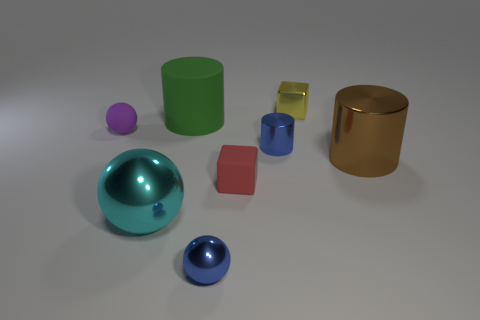There is a cylinder that is behind the blue metallic thing behind the large sphere; are there any purple rubber balls that are to the right of it?
Your answer should be very brief. No. Is there anything else that has the same size as the brown shiny thing?
Provide a succinct answer. Yes. There is a big cyan metallic object; does it have the same shape as the metallic object that is behind the tiny purple sphere?
Your response must be concise. No. There is a tiny metal thing that is in front of the small rubber thing that is in front of the small blue shiny thing that is behind the tiny blue ball; what is its color?
Offer a terse response. Blue. How many objects are balls right of the matte cylinder or small blue things in front of the big brown object?
Make the answer very short. 1. What number of other objects are the same color as the big metal cylinder?
Make the answer very short. 0. There is a large metal object right of the metallic block; does it have the same shape as the small purple rubber object?
Your answer should be compact. No. Are there fewer shiny blocks on the left side of the tiny purple object than large cyan spheres?
Provide a succinct answer. Yes. Is there a small object that has the same material as the tiny blue cylinder?
Your answer should be very brief. Yes. There is a green thing that is the same size as the cyan ball; what is it made of?
Offer a very short reply. Rubber. 